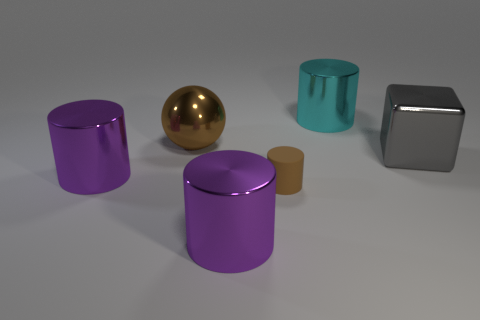There is a large cylinder that is behind the large purple cylinder on the left side of the purple cylinder that is right of the large brown object; what is its color?
Offer a terse response. Cyan. Is the shape of the tiny brown thing the same as the large brown shiny thing?
Ensure brevity in your answer.  No. What color is the big cube that is the same material as the large brown ball?
Offer a terse response. Gray. What number of objects are brown objects on the right side of the brown shiny ball or brown objects?
Your response must be concise. 2. What size is the purple metallic cylinder behind the brown rubber thing?
Offer a very short reply. Large. There is a gray block; is it the same size as the purple cylinder that is to the left of the big brown metallic object?
Give a very brief answer. Yes. What is the color of the shiny cylinder to the left of the purple metal cylinder that is in front of the rubber cylinder?
Offer a terse response. Purple. Are there an equal number of small yellow shiny objects and large cylinders?
Ensure brevity in your answer.  No. How many other things are there of the same color as the large metallic cube?
Make the answer very short. 0. What is the size of the ball?
Ensure brevity in your answer.  Large. 